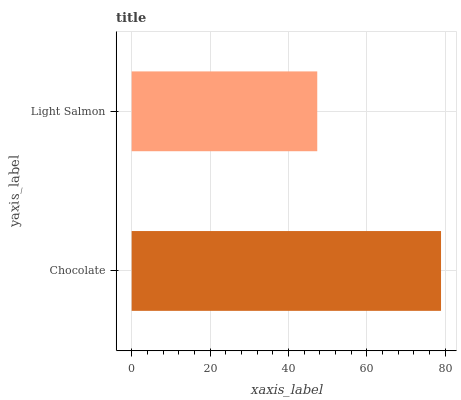Is Light Salmon the minimum?
Answer yes or no. Yes. Is Chocolate the maximum?
Answer yes or no. Yes. Is Light Salmon the maximum?
Answer yes or no. No. Is Chocolate greater than Light Salmon?
Answer yes or no. Yes. Is Light Salmon less than Chocolate?
Answer yes or no. Yes. Is Light Salmon greater than Chocolate?
Answer yes or no. No. Is Chocolate less than Light Salmon?
Answer yes or no. No. Is Chocolate the high median?
Answer yes or no. Yes. Is Light Salmon the low median?
Answer yes or no. Yes. Is Light Salmon the high median?
Answer yes or no. No. Is Chocolate the low median?
Answer yes or no. No. 